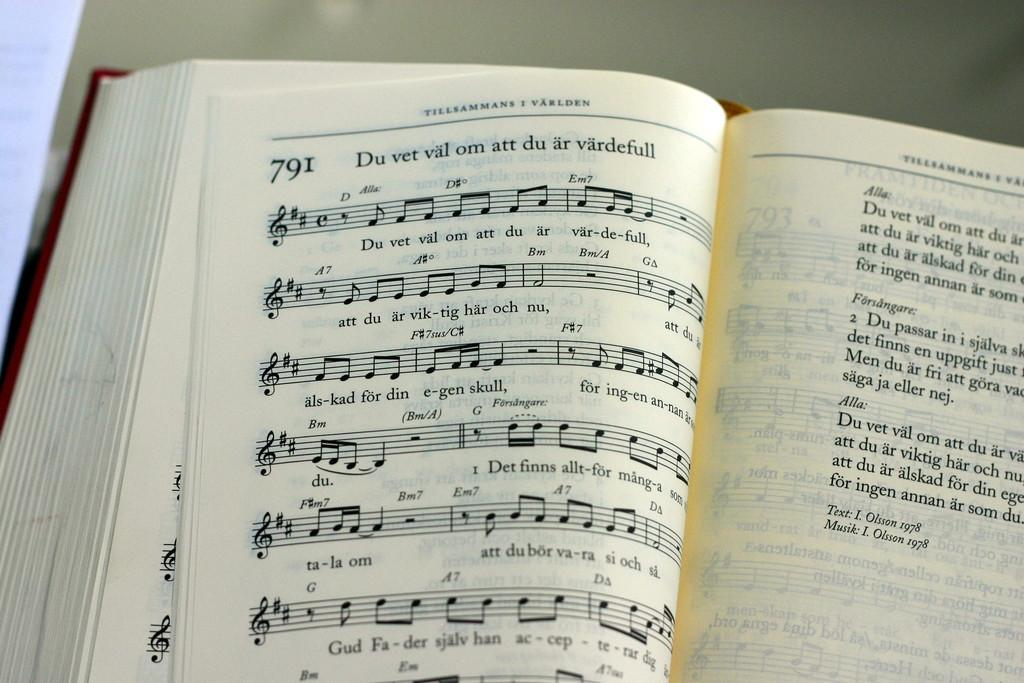Provide a one-sentence caption for the provided image. An open very thick hardback German music manuscript book shows song number 791. 